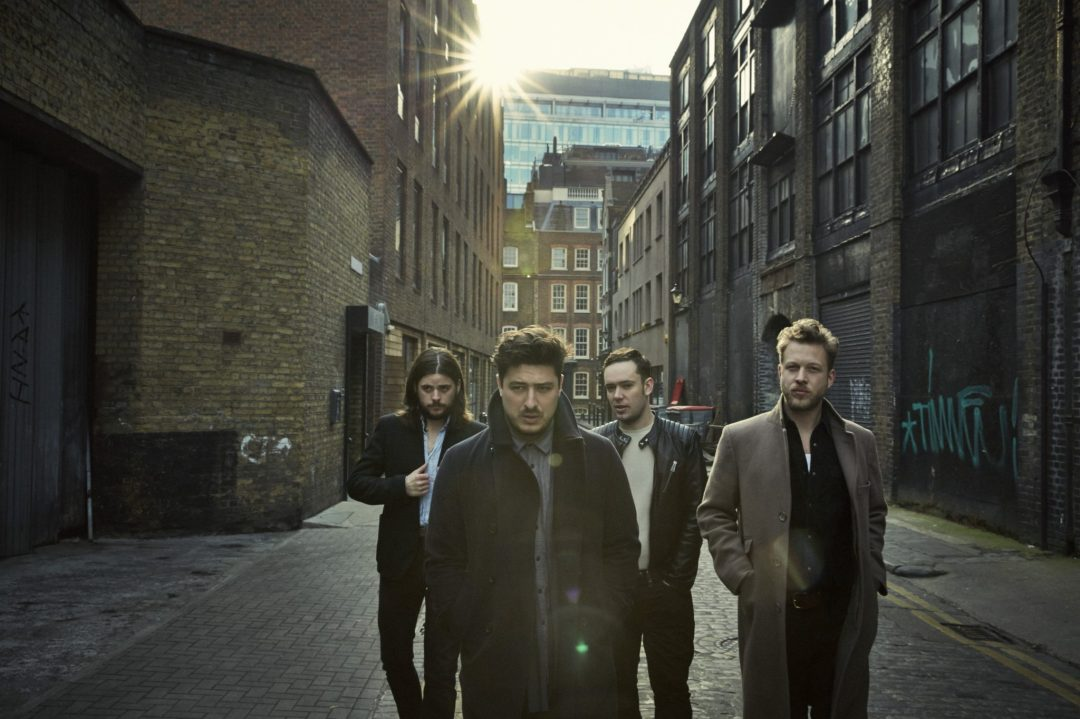What emotions or attitudes might the facial expressions and posture of these individuals convey? The expressions on their faces and their body language seem serious and focused. They're walking purposefully, projecting confidence. Their direct gazes and slightly furrowed brows could imply a sense of determination or an intent to convey a meaningful message through whatever project they're undertaking. 